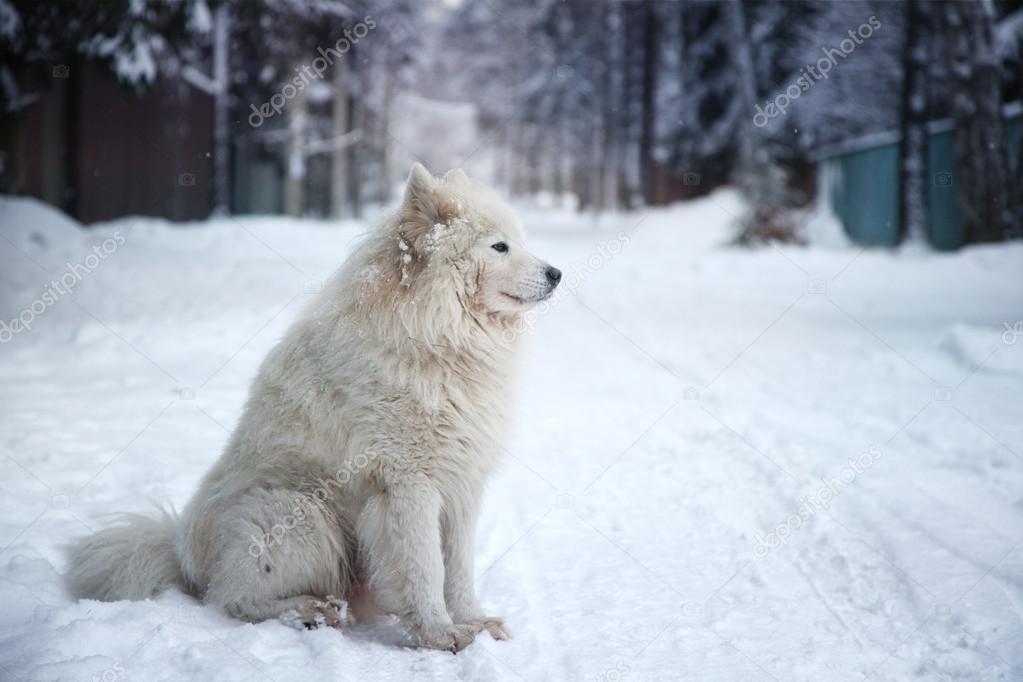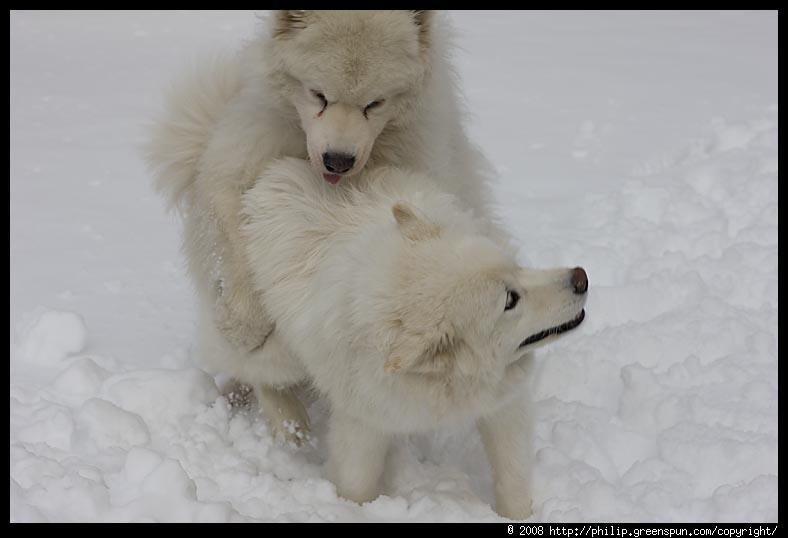The first image is the image on the left, the second image is the image on the right. Assess this claim about the two images: "There are exactly three dogs.". Correct or not? Answer yes or no. Yes. 